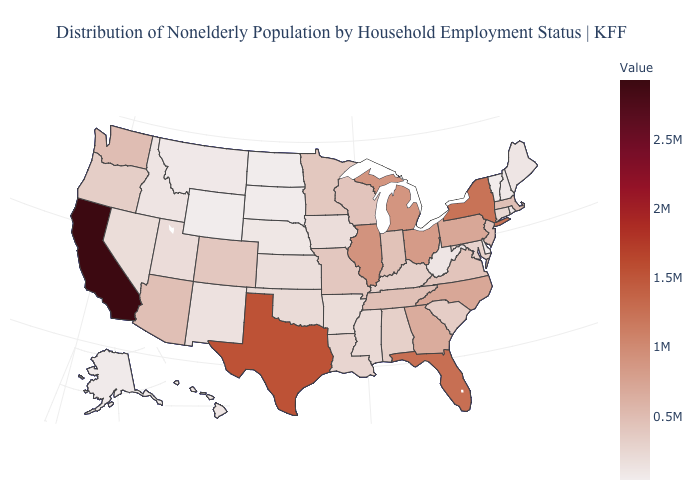Does Rhode Island have a higher value than Ohio?
Give a very brief answer. No. Among the states that border Nebraska , which have the highest value?
Concise answer only. Colorado. Among the states that border Iowa , does Minnesota have the lowest value?
Short answer required. No. Does Oregon have the highest value in the USA?
Be succinct. No. Among the states that border Nevada , which have the lowest value?
Quick response, please. Idaho. Which states have the lowest value in the USA?
Answer briefly. Wyoming. Does Indiana have a higher value than New York?
Answer briefly. No. 